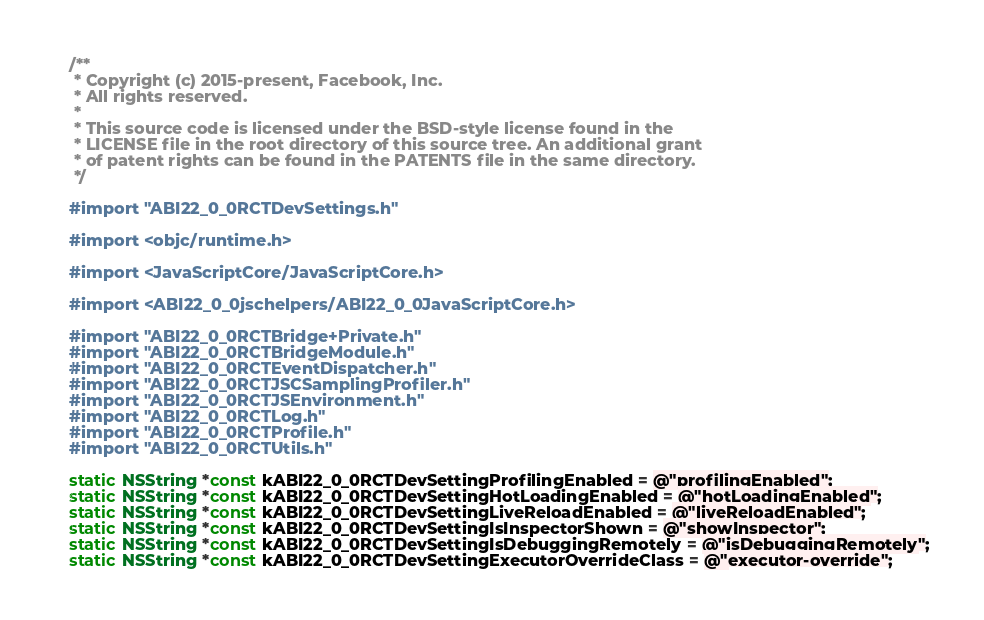<code> <loc_0><loc_0><loc_500><loc_500><_ObjectiveC_>/**
 * Copyright (c) 2015-present, Facebook, Inc.
 * All rights reserved.
 *
 * This source code is licensed under the BSD-style license found in the
 * LICENSE file in the root directory of this source tree. An additional grant
 * of patent rights can be found in the PATENTS file in the same directory.
 */

#import "ABI22_0_0RCTDevSettings.h"

#import <objc/runtime.h>

#import <JavaScriptCore/JavaScriptCore.h>

#import <ABI22_0_0jschelpers/ABI22_0_0JavaScriptCore.h>

#import "ABI22_0_0RCTBridge+Private.h"
#import "ABI22_0_0RCTBridgeModule.h"
#import "ABI22_0_0RCTEventDispatcher.h"
#import "ABI22_0_0RCTJSCSamplingProfiler.h"
#import "ABI22_0_0RCTJSEnvironment.h"
#import "ABI22_0_0RCTLog.h"
#import "ABI22_0_0RCTProfile.h"
#import "ABI22_0_0RCTUtils.h"

static NSString *const kABI22_0_0RCTDevSettingProfilingEnabled = @"profilingEnabled";
static NSString *const kABI22_0_0RCTDevSettingHotLoadingEnabled = @"hotLoadingEnabled";
static NSString *const kABI22_0_0RCTDevSettingLiveReloadEnabled = @"liveReloadEnabled";
static NSString *const kABI22_0_0RCTDevSettingIsInspectorShown = @"showInspector";
static NSString *const kABI22_0_0RCTDevSettingIsDebuggingRemotely = @"isDebuggingRemotely";
static NSString *const kABI22_0_0RCTDevSettingExecutorOverrideClass = @"executor-override";</code> 